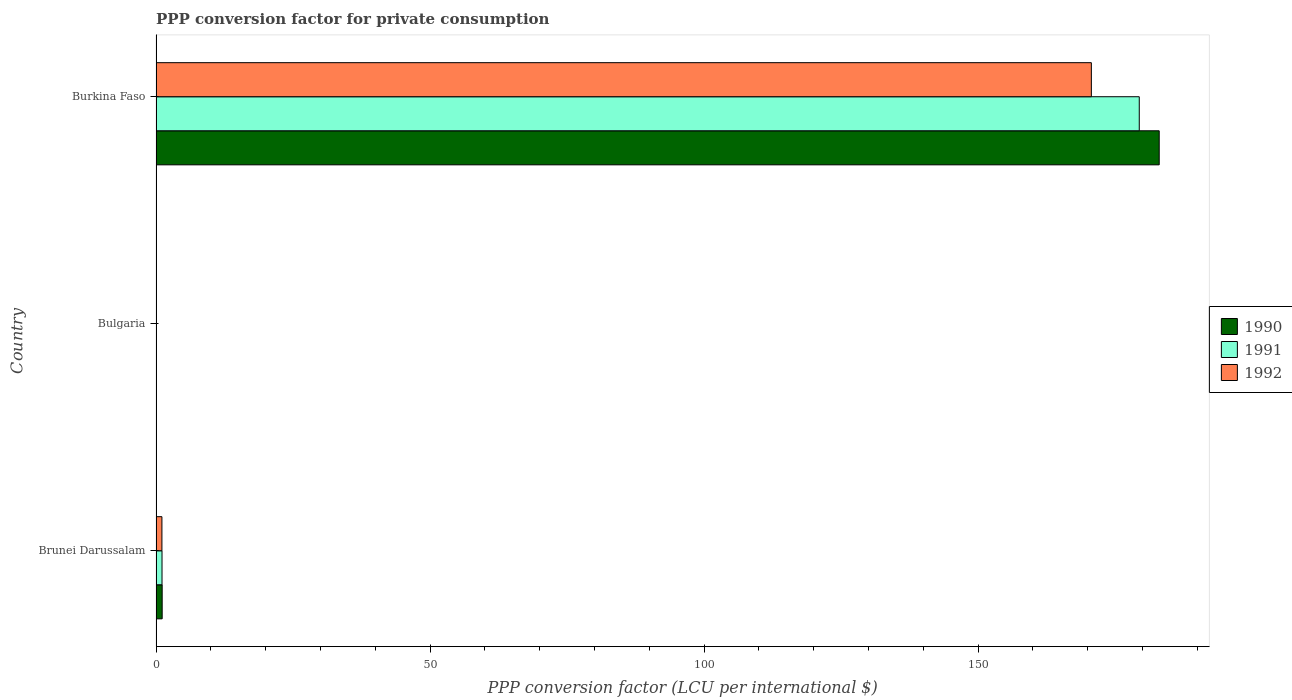How many different coloured bars are there?
Offer a very short reply. 3. Are the number of bars per tick equal to the number of legend labels?
Offer a very short reply. Yes. Are the number of bars on each tick of the Y-axis equal?
Provide a short and direct response. Yes. How many bars are there on the 2nd tick from the top?
Keep it short and to the point. 3. How many bars are there on the 2nd tick from the bottom?
Provide a short and direct response. 3. What is the label of the 3rd group of bars from the top?
Your answer should be compact. Brunei Darussalam. In how many cases, is the number of bars for a given country not equal to the number of legend labels?
Ensure brevity in your answer.  0. What is the PPP conversion factor for private consumption in 1991 in Bulgaria?
Your answer should be compact. 0. Across all countries, what is the maximum PPP conversion factor for private consumption in 1991?
Ensure brevity in your answer.  179.42. Across all countries, what is the minimum PPP conversion factor for private consumption in 1991?
Offer a terse response. 0. In which country was the PPP conversion factor for private consumption in 1991 maximum?
Provide a short and direct response. Burkina Faso. What is the total PPP conversion factor for private consumption in 1990 in the graph?
Your answer should be very brief. 184.18. What is the difference between the PPP conversion factor for private consumption in 1992 in Brunei Darussalam and that in Burkina Faso?
Provide a succinct answer. -169.6. What is the difference between the PPP conversion factor for private consumption in 1992 in Burkina Faso and the PPP conversion factor for private consumption in 1991 in Brunei Darussalam?
Make the answer very short. 169.58. What is the average PPP conversion factor for private consumption in 1992 per country?
Make the answer very short. 57.25. What is the difference between the PPP conversion factor for private consumption in 1992 and PPP conversion factor for private consumption in 1991 in Brunei Darussalam?
Offer a very short reply. -0.02. What is the ratio of the PPP conversion factor for private consumption in 1992 in Brunei Darussalam to that in Burkina Faso?
Offer a terse response. 0.01. Is the PPP conversion factor for private consumption in 1992 in Brunei Darussalam less than that in Bulgaria?
Offer a very short reply. No. Is the difference between the PPP conversion factor for private consumption in 1992 in Brunei Darussalam and Bulgaria greater than the difference between the PPP conversion factor for private consumption in 1991 in Brunei Darussalam and Bulgaria?
Offer a very short reply. No. What is the difference between the highest and the second highest PPP conversion factor for private consumption in 1990?
Offer a very short reply. 181.93. What is the difference between the highest and the lowest PPP conversion factor for private consumption in 1991?
Give a very brief answer. 179.41. In how many countries, is the PPP conversion factor for private consumption in 1991 greater than the average PPP conversion factor for private consumption in 1991 taken over all countries?
Keep it short and to the point. 1. How many countries are there in the graph?
Your answer should be compact. 3. What is the difference between two consecutive major ticks on the X-axis?
Keep it short and to the point. 50. Does the graph contain grids?
Ensure brevity in your answer.  No. What is the title of the graph?
Provide a succinct answer. PPP conversion factor for private consumption. Does "1982" appear as one of the legend labels in the graph?
Provide a short and direct response. No. What is the label or title of the X-axis?
Keep it short and to the point. PPP conversion factor (LCU per international $). What is the label or title of the Y-axis?
Make the answer very short. Country. What is the PPP conversion factor (LCU per international $) in 1990 in Brunei Darussalam?
Your answer should be very brief. 1.12. What is the PPP conversion factor (LCU per international $) in 1991 in Brunei Darussalam?
Offer a very short reply. 1.09. What is the PPP conversion factor (LCU per international $) of 1992 in Brunei Darussalam?
Keep it short and to the point. 1.08. What is the PPP conversion factor (LCU per international $) of 1990 in Bulgaria?
Your response must be concise. 0. What is the PPP conversion factor (LCU per international $) in 1991 in Bulgaria?
Ensure brevity in your answer.  0. What is the PPP conversion factor (LCU per international $) of 1992 in Bulgaria?
Keep it short and to the point. 0. What is the PPP conversion factor (LCU per international $) in 1990 in Burkina Faso?
Your answer should be very brief. 183.06. What is the PPP conversion factor (LCU per international $) of 1991 in Burkina Faso?
Make the answer very short. 179.42. What is the PPP conversion factor (LCU per international $) in 1992 in Burkina Faso?
Provide a succinct answer. 170.67. Across all countries, what is the maximum PPP conversion factor (LCU per international $) in 1990?
Your answer should be compact. 183.06. Across all countries, what is the maximum PPP conversion factor (LCU per international $) in 1991?
Provide a short and direct response. 179.42. Across all countries, what is the maximum PPP conversion factor (LCU per international $) of 1992?
Give a very brief answer. 170.67. Across all countries, what is the minimum PPP conversion factor (LCU per international $) in 1990?
Provide a short and direct response. 0. Across all countries, what is the minimum PPP conversion factor (LCU per international $) in 1991?
Ensure brevity in your answer.  0. Across all countries, what is the minimum PPP conversion factor (LCU per international $) in 1992?
Your answer should be compact. 0. What is the total PPP conversion factor (LCU per international $) in 1990 in the graph?
Your response must be concise. 184.18. What is the total PPP conversion factor (LCU per international $) of 1991 in the graph?
Ensure brevity in your answer.  180.51. What is the total PPP conversion factor (LCU per international $) of 1992 in the graph?
Your answer should be compact. 171.76. What is the difference between the PPP conversion factor (LCU per international $) in 1990 in Brunei Darussalam and that in Bulgaria?
Provide a short and direct response. 1.12. What is the difference between the PPP conversion factor (LCU per international $) in 1991 in Brunei Darussalam and that in Bulgaria?
Give a very brief answer. 1.09. What is the difference between the PPP conversion factor (LCU per international $) in 1992 in Brunei Darussalam and that in Bulgaria?
Make the answer very short. 1.07. What is the difference between the PPP conversion factor (LCU per international $) of 1990 in Brunei Darussalam and that in Burkina Faso?
Provide a short and direct response. -181.93. What is the difference between the PPP conversion factor (LCU per international $) of 1991 in Brunei Darussalam and that in Burkina Faso?
Make the answer very short. -178.32. What is the difference between the PPP conversion factor (LCU per international $) of 1992 in Brunei Darussalam and that in Burkina Faso?
Provide a succinct answer. -169.6. What is the difference between the PPP conversion factor (LCU per international $) in 1990 in Bulgaria and that in Burkina Faso?
Provide a succinct answer. -183.06. What is the difference between the PPP conversion factor (LCU per international $) in 1991 in Bulgaria and that in Burkina Faso?
Offer a terse response. -179.41. What is the difference between the PPP conversion factor (LCU per international $) of 1992 in Bulgaria and that in Burkina Faso?
Give a very brief answer. -170.67. What is the difference between the PPP conversion factor (LCU per international $) of 1990 in Brunei Darussalam and the PPP conversion factor (LCU per international $) of 1991 in Bulgaria?
Your answer should be compact. 1.12. What is the difference between the PPP conversion factor (LCU per international $) of 1990 in Brunei Darussalam and the PPP conversion factor (LCU per international $) of 1992 in Bulgaria?
Keep it short and to the point. 1.12. What is the difference between the PPP conversion factor (LCU per international $) of 1991 in Brunei Darussalam and the PPP conversion factor (LCU per international $) of 1992 in Bulgaria?
Provide a succinct answer. 1.09. What is the difference between the PPP conversion factor (LCU per international $) in 1990 in Brunei Darussalam and the PPP conversion factor (LCU per international $) in 1991 in Burkina Faso?
Make the answer very short. -178.29. What is the difference between the PPP conversion factor (LCU per international $) in 1990 in Brunei Darussalam and the PPP conversion factor (LCU per international $) in 1992 in Burkina Faso?
Offer a terse response. -169.55. What is the difference between the PPP conversion factor (LCU per international $) in 1991 in Brunei Darussalam and the PPP conversion factor (LCU per international $) in 1992 in Burkina Faso?
Make the answer very short. -169.58. What is the difference between the PPP conversion factor (LCU per international $) of 1990 in Bulgaria and the PPP conversion factor (LCU per international $) of 1991 in Burkina Faso?
Provide a short and direct response. -179.42. What is the difference between the PPP conversion factor (LCU per international $) of 1990 in Bulgaria and the PPP conversion factor (LCU per international $) of 1992 in Burkina Faso?
Your answer should be compact. -170.67. What is the difference between the PPP conversion factor (LCU per international $) of 1991 in Bulgaria and the PPP conversion factor (LCU per international $) of 1992 in Burkina Faso?
Provide a short and direct response. -170.67. What is the average PPP conversion factor (LCU per international $) in 1990 per country?
Your answer should be very brief. 61.39. What is the average PPP conversion factor (LCU per international $) of 1991 per country?
Keep it short and to the point. 60.17. What is the average PPP conversion factor (LCU per international $) in 1992 per country?
Keep it short and to the point. 57.25. What is the difference between the PPP conversion factor (LCU per international $) in 1990 and PPP conversion factor (LCU per international $) in 1991 in Brunei Darussalam?
Your response must be concise. 0.03. What is the difference between the PPP conversion factor (LCU per international $) in 1990 and PPP conversion factor (LCU per international $) in 1992 in Brunei Darussalam?
Your answer should be compact. 0.05. What is the difference between the PPP conversion factor (LCU per international $) in 1991 and PPP conversion factor (LCU per international $) in 1992 in Brunei Darussalam?
Keep it short and to the point. 0.02. What is the difference between the PPP conversion factor (LCU per international $) of 1990 and PPP conversion factor (LCU per international $) of 1991 in Bulgaria?
Provide a succinct answer. -0. What is the difference between the PPP conversion factor (LCU per international $) in 1990 and PPP conversion factor (LCU per international $) in 1992 in Bulgaria?
Your response must be concise. -0. What is the difference between the PPP conversion factor (LCU per international $) in 1991 and PPP conversion factor (LCU per international $) in 1992 in Bulgaria?
Your response must be concise. -0. What is the difference between the PPP conversion factor (LCU per international $) of 1990 and PPP conversion factor (LCU per international $) of 1991 in Burkina Faso?
Provide a short and direct response. 3.64. What is the difference between the PPP conversion factor (LCU per international $) of 1990 and PPP conversion factor (LCU per international $) of 1992 in Burkina Faso?
Ensure brevity in your answer.  12.38. What is the difference between the PPP conversion factor (LCU per international $) of 1991 and PPP conversion factor (LCU per international $) of 1992 in Burkina Faso?
Ensure brevity in your answer.  8.74. What is the ratio of the PPP conversion factor (LCU per international $) in 1990 in Brunei Darussalam to that in Bulgaria?
Ensure brevity in your answer.  1773.71. What is the ratio of the PPP conversion factor (LCU per international $) in 1991 in Brunei Darussalam to that in Bulgaria?
Give a very brief answer. 411.02. What is the ratio of the PPP conversion factor (LCU per international $) in 1992 in Brunei Darussalam to that in Bulgaria?
Your answer should be compact. 217.61. What is the ratio of the PPP conversion factor (LCU per international $) in 1990 in Brunei Darussalam to that in Burkina Faso?
Keep it short and to the point. 0.01. What is the ratio of the PPP conversion factor (LCU per international $) in 1991 in Brunei Darussalam to that in Burkina Faso?
Offer a very short reply. 0.01. What is the ratio of the PPP conversion factor (LCU per international $) of 1992 in Brunei Darussalam to that in Burkina Faso?
Make the answer very short. 0.01. What is the ratio of the PPP conversion factor (LCU per international $) of 1990 in Bulgaria to that in Burkina Faso?
Offer a very short reply. 0. What is the ratio of the PPP conversion factor (LCU per international $) in 1991 in Bulgaria to that in Burkina Faso?
Your answer should be compact. 0. What is the ratio of the PPP conversion factor (LCU per international $) in 1992 in Bulgaria to that in Burkina Faso?
Make the answer very short. 0. What is the difference between the highest and the second highest PPP conversion factor (LCU per international $) in 1990?
Your answer should be very brief. 181.93. What is the difference between the highest and the second highest PPP conversion factor (LCU per international $) of 1991?
Provide a succinct answer. 178.32. What is the difference between the highest and the second highest PPP conversion factor (LCU per international $) of 1992?
Your response must be concise. 169.6. What is the difference between the highest and the lowest PPP conversion factor (LCU per international $) of 1990?
Provide a short and direct response. 183.06. What is the difference between the highest and the lowest PPP conversion factor (LCU per international $) in 1991?
Make the answer very short. 179.41. What is the difference between the highest and the lowest PPP conversion factor (LCU per international $) in 1992?
Provide a short and direct response. 170.67. 